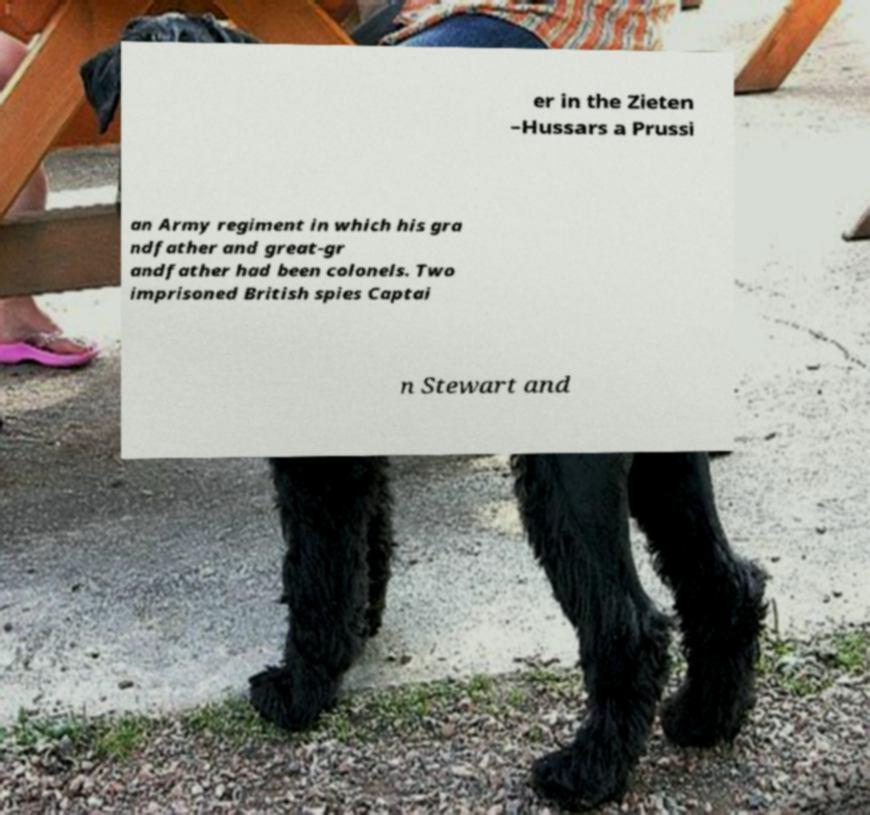I need the written content from this picture converted into text. Can you do that? er in the Zieten –Hussars a Prussi an Army regiment in which his gra ndfather and great-gr andfather had been colonels. Two imprisoned British spies Captai n Stewart and 